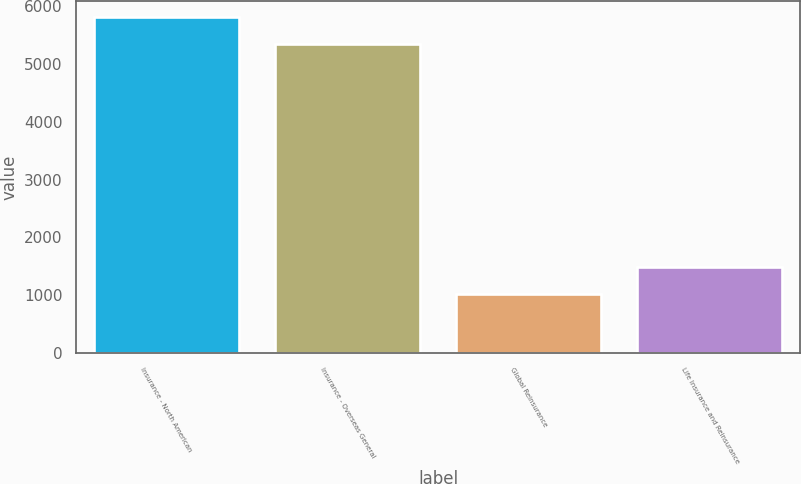Convert chart to OTSL. <chart><loc_0><loc_0><loc_500><loc_500><bar_chart><fcel>Insurance - North American<fcel>Insurance - Overseas General<fcel>Global Reinsurance<fcel>Life Insurance and Reinsurance<nl><fcel>5803.2<fcel>5337<fcel>1017<fcel>1483.2<nl></chart> 